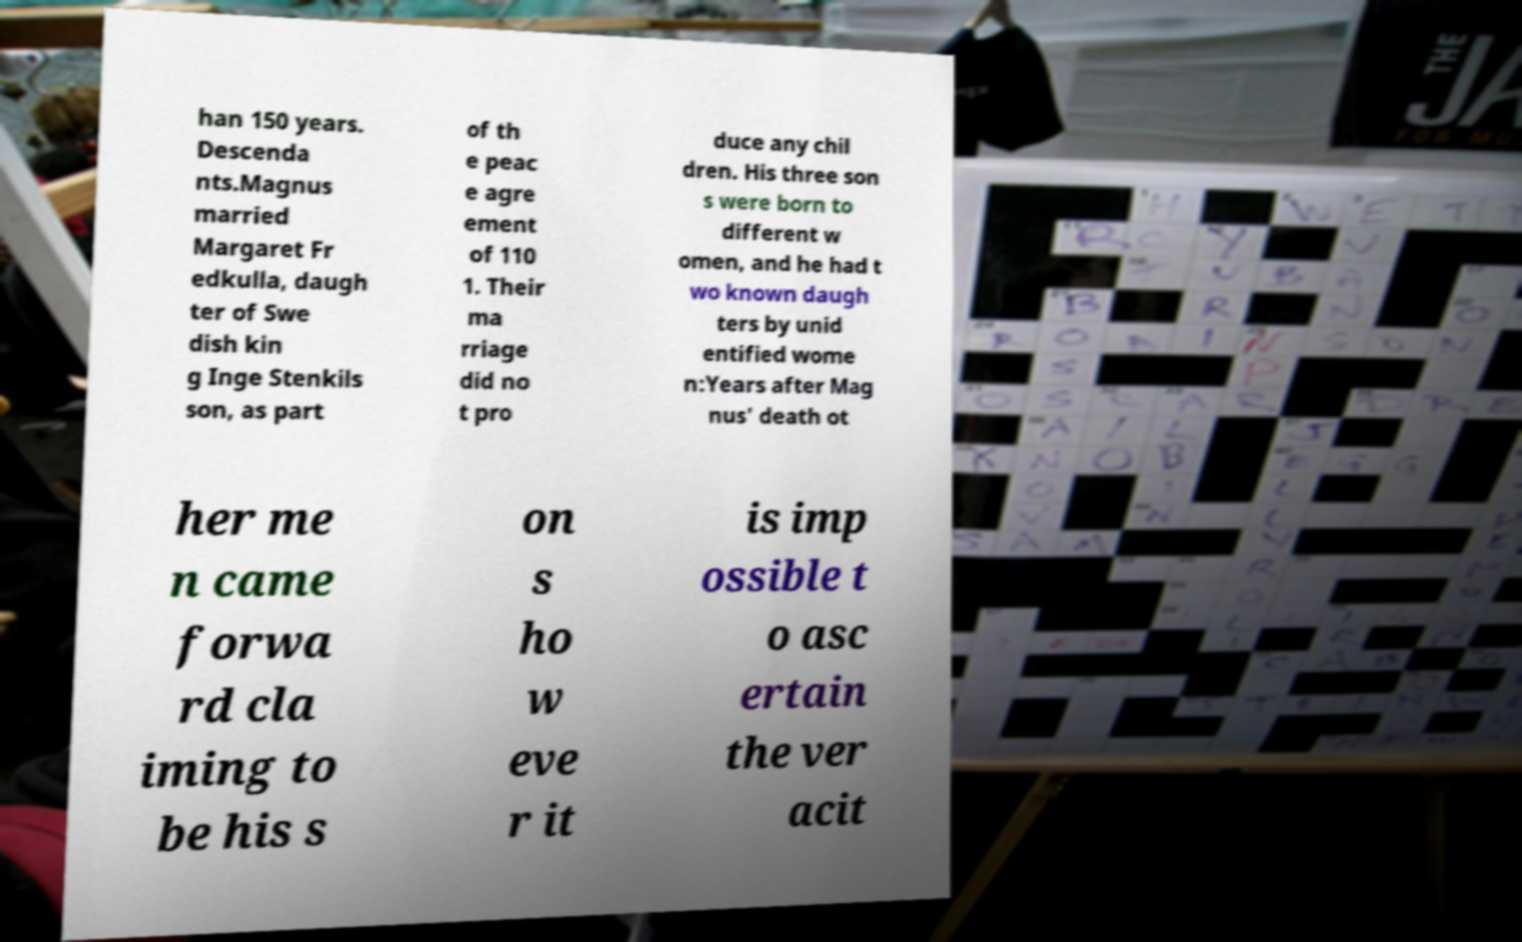Can you read and provide the text displayed in the image?This photo seems to have some interesting text. Can you extract and type it out for me? han 150 years. Descenda nts.Magnus married Margaret Fr edkulla, daugh ter of Swe dish kin g Inge Stenkils son, as part of th e peac e agre ement of 110 1. Their ma rriage did no t pro duce any chil dren. His three son s were born to different w omen, and he had t wo known daugh ters by unid entified wome n:Years after Mag nus' death ot her me n came forwa rd cla iming to be his s on s ho w eve r it is imp ossible t o asc ertain the ver acit 